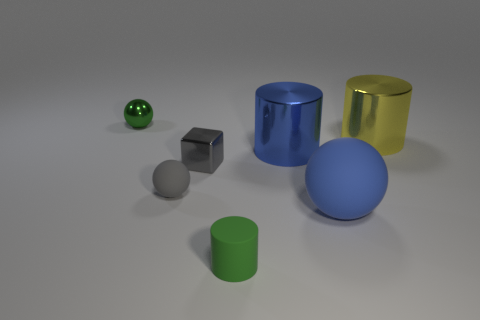There is a tiny metal thing that is right of the small metallic ball; is its color the same as the tiny rubber cylinder?
Offer a terse response. No. What size is the green metal thing that is the same shape as the gray rubber thing?
Provide a succinct answer. Small. Is there any other thing that has the same material as the tiny block?
Ensure brevity in your answer.  Yes. Is there a tiny metallic object on the right side of the small metallic thing on the right side of the small object that is behind the small gray metallic object?
Provide a succinct answer. No. What is the material of the green object in front of the green metal object?
Keep it short and to the point. Rubber. What number of tiny objects are either green things or cyan metal things?
Ensure brevity in your answer.  2. Does the sphere that is behind the yellow object have the same size as the green matte object?
Provide a succinct answer. Yes. What number of other objects are the same color as the small cylinder?
Offer a terse response. 1. What is the small cylinder made of?
Make the answer very short. Rubber. There is a sphere that is in front of the blue metal object and to the left of the large ball; what material is it?
Ensure brevity in your answer.  Rubber. 